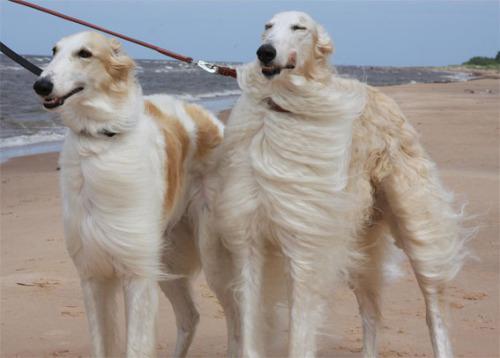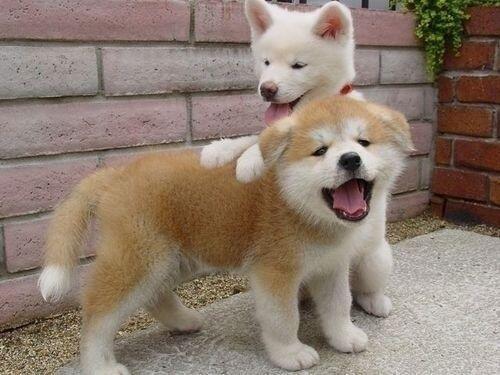The first image is the image on the left, the second image is the image on the right. Given the left and right images, does the statement "The left image contains three dogs." hold true? Answer yes or no. No. The first image is the image on the left, the second image is the image on the right. Assess this claim about the two images: "The right image contains one hound standing in profile with its body turned leftward, and the left image contains three hounds with their heads not all pointed in the same direction.". Correct or not? Answer yes or no. No. 